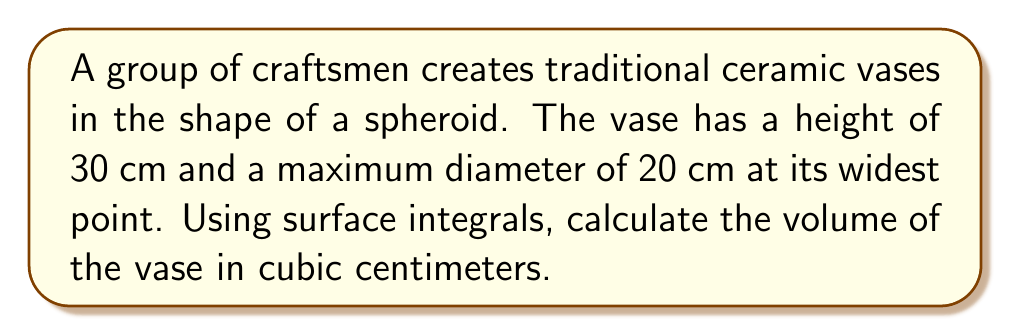Give your solution to this math problem. Let's approach this step-by-step:

1) A spheroid is formed by rotating an ellipse around one of its axes. In this case, we're rotating around the vertical axis.

2) The equation of the ellipse in the xz-plane is:

   $$\frac{x^2}{a^2} + \frac{z^2}{b^2} = 1$$

   where $a$ is the radius at the widest point (10 cm) and $b$ is half the height (15 cm).

3) To find the volume, we'll use the surface integral:

   $$V = \int_{-b}^{b} \pi x^2 dz$$

4) We need to express $x$ in terms of $z$:

   $$x^2 = a^2(1 - \frac{z^2}{b^2})$$

5) Substituting this into our volume integral:

   $$V = \int_{-15}^{15} \pi a^2(1 - \frac{z^2}{b^2}) dz$$

6) Simplifying:

   $$V = \pi a^2 \int_{-15}^{15} (1 - \frac{z^2}{b^2}) dz$$

7) Evaluating the integral:

   $$V = \pi a^2 [z - \frac{z^3}{3b^2}]_{-15}^{15}$$

8) Substituting the limits:

   $$V = \pi a^2 [(15 - \frac{15^3}{3b^2}) - (-15 - \frac{(-15)^3}{3b^2})]$$

9) Simplifying:

   $$V = \pi a^2 [30 - \frac{2 \cdot 15^3}{3b^2}]$$

10) Substituting values ($a = 10$, $b = 15$):

    $$V = \pi \cdot 10^2 [30 - \frac{2 \cdot 15^3}{3 \cdot 15^2}]$$
    $$V = 100\pi [30 - \frac{2 \cdot 15}{3}]$$
    $$V = 100\pi [30 - 10]$$
    $$V = 2000\pi$$

11) Calculate the final value:

    $$V \approx 6283.19 \text{ cm}^3$$
Answer: 6283.19 cm³ 